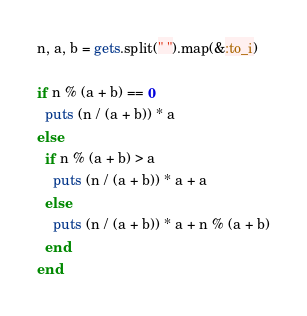Convert code to text. <code><loc_0><loc_0><loc_500><loc_500><_Ruby_>n, a, b = gets.split(" ").map(&:to_i)
 
if n % (a + b) == 0
  puts (n / (a + b)) * a
else
  if n % (a + b) > a
    puts (n / (a + b)) * a + a
  else
    puts (n / (a + b)) * a + n % (a + b)
  end
end</code> 